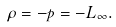<formula> <loc_0><loc_0><loc_500><loc_500>\rho = - p = - L _ { \infty } .</formula> 